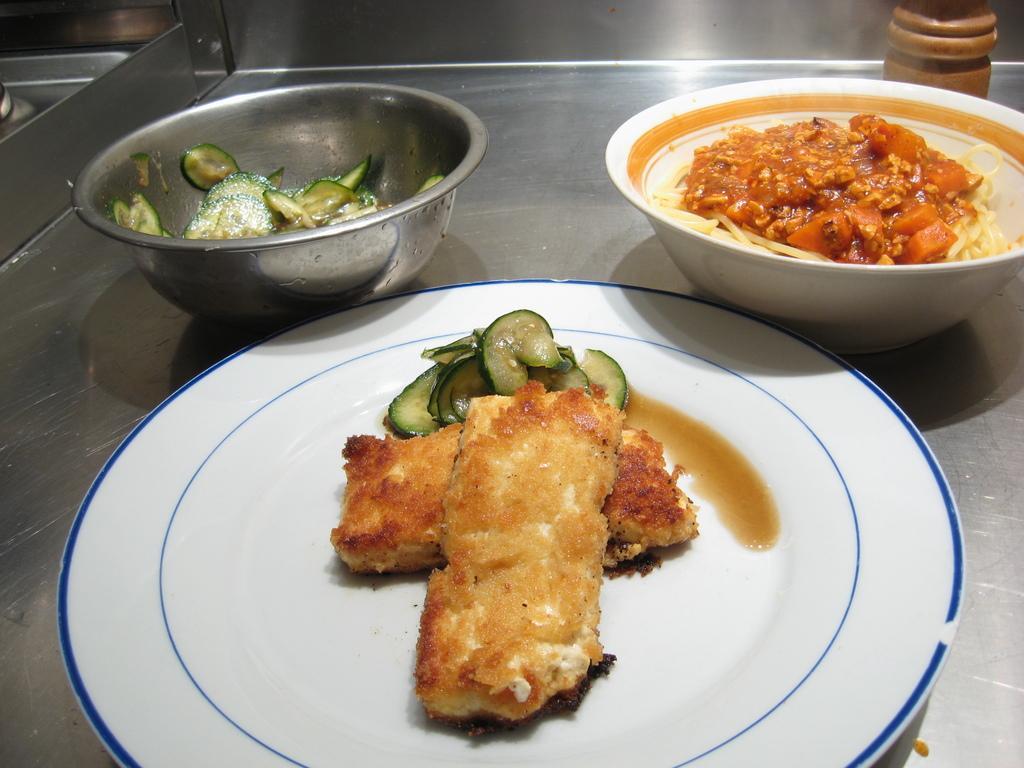Describe this image in one or two sentences. In the center of the image we can see an object. On the object, we can see one plate, bowls, some food items and some objects. 